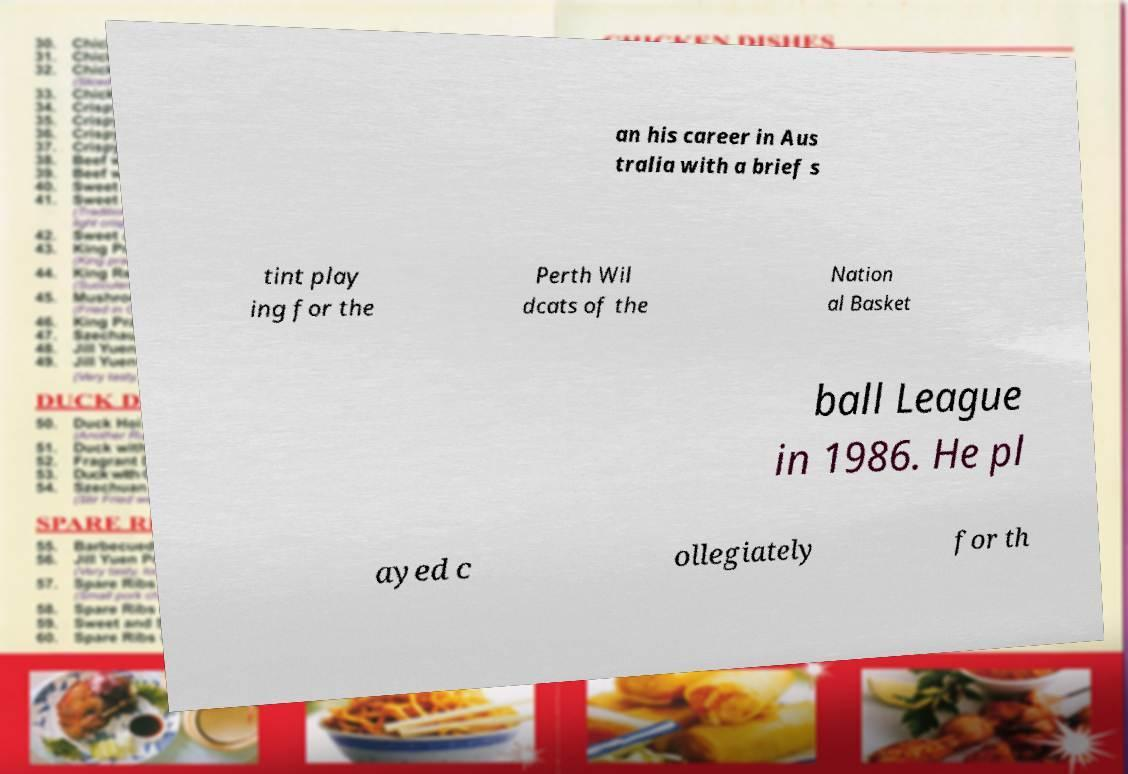Please read and relay the text visible in this image. What does it say? an his career in Aus tralia with a brief s tint play ing for the Perth Wil dcats of the Nation al Basket ball League in 1986. He pl ayed c ollegiately for th 